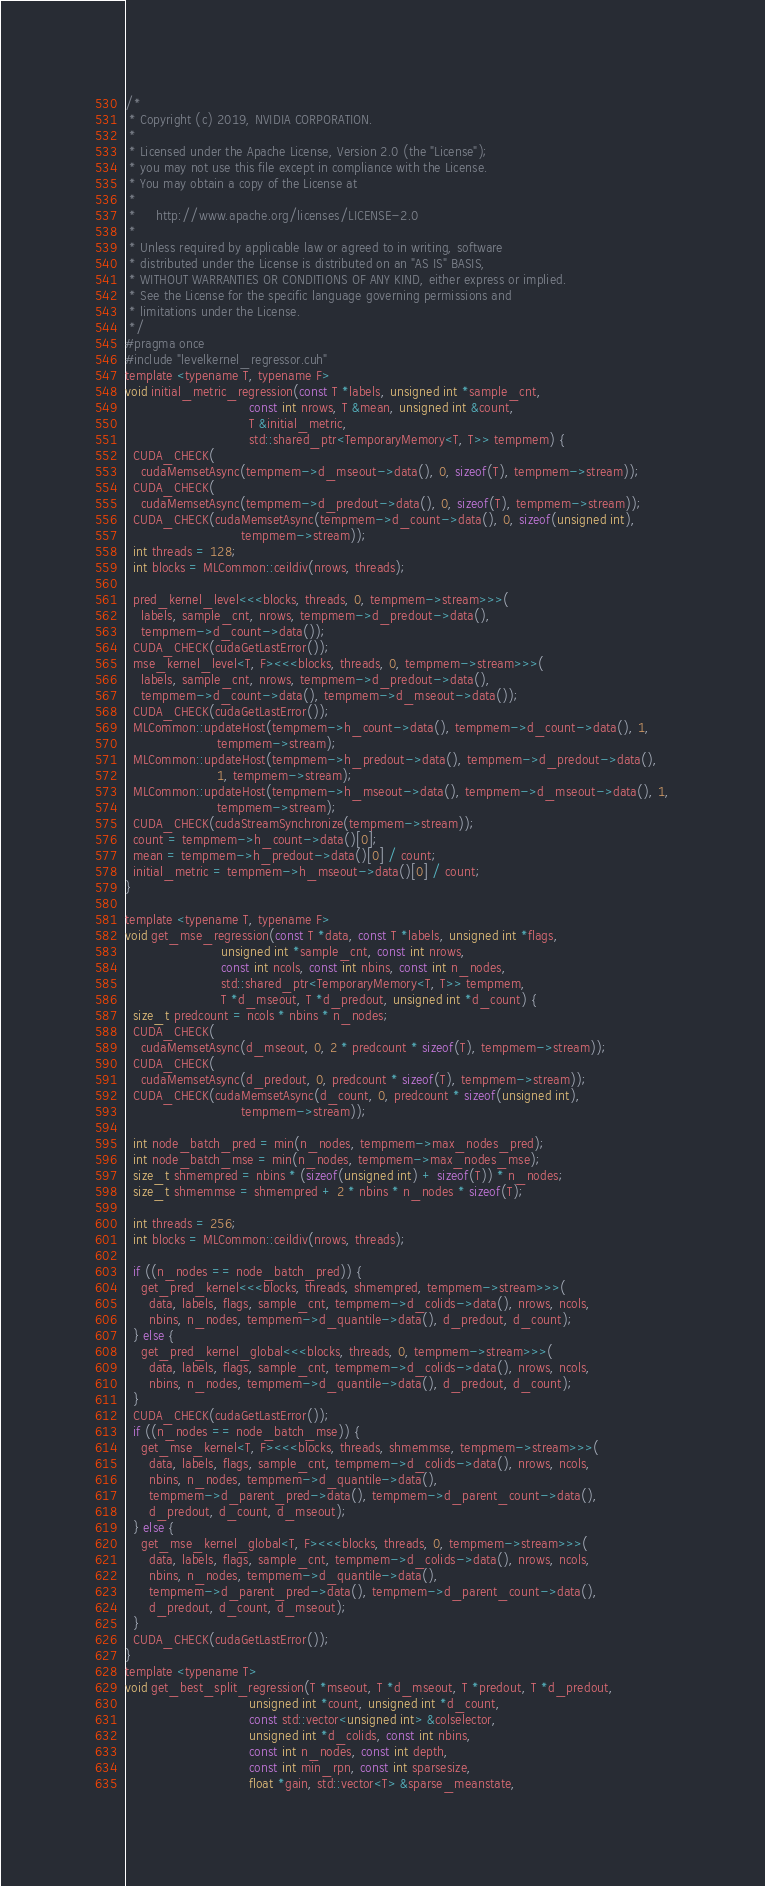Convert code to text. <code><loc_0><loc_0><loc_500><loc_500><_Cuda_>/*
 * Copyright (c) 2019, NVIDIA CORPORATION.
 *
 * Licensed under the Apache License, Version 2.0 (the "License");
 * you may not use this file except in compliance with the License.
 * You may obtain a copy of the License at
 *
 *     http://www.apache.org/licenses/LICENSE-2.0
 *
 * Unless required by applicable law or agreed to in writing, software
 * distributed under the License is distributed on an "AS IS" BASIS,
 * WITHOUT WARRANTIES OR CONDITIONS OF ANY KIND, either express or implied.
 * See the License for the specific language governing permissions and
 * limitations under the License.
 */
#pragma once
#include "levelkernel_regressor.cuh"
template <typename T, typename F>
void initial_metric_regression(const T *labels, unsigned int *sample_cnt,
                               const int nrows, T &mean, unsigned int &count,
                               T &initial_metric,
                               std::shared_ptr<TemporaryMemory<T, T>> tempmem) {
  CUDA_CHECK(
    cudaMemsetAsync(tempmem->d_mseout->data(), 0, sizeof(T), tempmem->stream));
  CUDA_CHECK(
    cudaMemsetAsync(tempmem->d_predout->data(), 0, sizeof(T), tempmem->stream));
  CUDA_CHECK(cudaMemsetAsync(tempmem->d_count->data(), 0, sizeof(unsigned int),
                             tempmem->stream));
  int threads = 128;
  int blocks = MLCommon::ceildiv(nrows, threads);

  pred_kernel_level<<<blocks, threads, 0, tempmem->stream>>>(
    labels, sample_cnt, nrows, tempmem->d_predout->data(),
    tempmem->d_count->data());
  CUDA_CHECK(cudaGetLastError());
  mse_kernel_level<T, F><<<blocks, threads, 0, tempmem->stream>>>(
    labels, sample_cnt, nrows, tempmem->d_predout->data(),
    tempmem->d_count->data(), tempmem->d_mseout->data());
  CUDA_CHECK(cudaGetLastError());
  MLCommon::updateHost(tempmem->h_count->data(), tempmem->d_count->data(), 1,
                       tempmem->stream);
  MLCommon::updateHost(tempmem->h_predout->data(), tempmem->d_predout->data(),
                       1, tempmem->stream);
  MLCommon::updateHost(tempmem->h_mseout->data(), tempmem->d_mseout->data(), 1,
                       tempmem->stream);
  CUDA_CHECK(cudaStreamSynchronize(tempmem->stream));
  count = tempmem->h_count->data()[0];
  mean = tempmem->h_predout->data()[0] / count;
  initial_metric = tempmem->h_mseout->data()[0] / count;
}

template <typename T, typename F>
void get_mse_regression(const T *data, const T *labels, unsigned int *flags,
                        unsigned int *sample_cnt, const int nrows,
                        const int ncols, const int nbins, const int n_nodes,
                        std::shared_ptr<TemporaryMemory<T, T>> tempmem,
                        T *d_mseout, T *d_predout, unsigned int *d_count) {
  size_t predcount = ncols * nbins * n_nodes;
  CUDA_CHECK(
    cudaMemsetAsync(d_mseout, 0, 2 * predcount * sizeof(T), tempmem->stream));
  CUDA_CHECK(
    cudaMemsetAsync(d_predout, 0, predcount * sizeof(T), tempmem->stream));
  CUDA_CHECK(cudaMemsetAsync(d_count, 0, predcount * sizeof(unsigned int),
                             tempmem->stream));

  int node_batch_pred = min(n_nodes, tempmem->max_nodes_pred);
  int node_batch_mse = min(n_nodes, tempmem->max_nodes_mse);
  size_t shmempred = nbins * (sizeof(unsigned int) + sizeof(T)) * n_nodes;
  size_t shmemmse = shmempred + 2 * nbins * n_nodes * sizeof(T);

  int threads = 256;
  int blocks = MLCommon::ceildiv(nrows, threads);

  if ((n_nodes == node_batch_pred)) {
    get_pred_kernel<<<blocks, threads, shmempred, tempmem->stream>>>(
      data, labels, flags, sample_cnt, tempmem->d_colids->data(), nrows, ncols,
      nbins, n_nodes, tempmem->d_quantile->data(), d_predout, d_count);
  } else {
    get_pred_kernel_global<<<blocks, threads, 0, tempmem->stream>>>(
      data, labels, flags, sample_cnt, tempmem->d_colids->data(), nrows, ncols,
      nbins, n_nodes, tempmem->d_quantile->data(), d_predout, d_count);
  }
  CUDA_CHECK(cudaGetLastError());
  if ((n_nodes == node_batch_mse)) {
    get_mse_kernel<T, F><<<blocks, threads, shmemmse, tempmem->stream>>>(
      data, labels, flags, sample_cnt, tempmem->d_colids->data(), nrows, ncols,
      nbins, n_nodes, tempmem->d_quantile->data(),
      tempmem->d_parent_pred->data(), tempmem->d_parent_count->data(),
      d_predout, d_count, d_mseout);
  } else {
    get_mse_kernel_global<T, F><<<blocks, threads, 0, tempmem->stream>>>(
      data, labels, flags, sample_cnt, tempmem->d_colids->data(), nrows, ncols,
      nbins, n_nodes, tempmem->d_quantile->data(),
      tempmem->d_parent_pred->data(), tempmem->d_parent_count->data(),
      d_predout, d_count, d_mseout);
  }
  CUDA_CHECK(cudaGetLastError());
}
template <typename T>
void get_best_split_regression(T *mseout, T *d_mseout, T *predout, T *d_predout,
                               unsigned int *count, unsigned int *d_count,
                               const std::vector<unsigned int> &colselector,
                               unsigned int *d_colids, const int nbins,
                               const int n_nodes, const int depth,
                               const int min_rpn, const int sparsesize,
                               float *gain, std::vector<T> &sparse_meanstate,</code> 